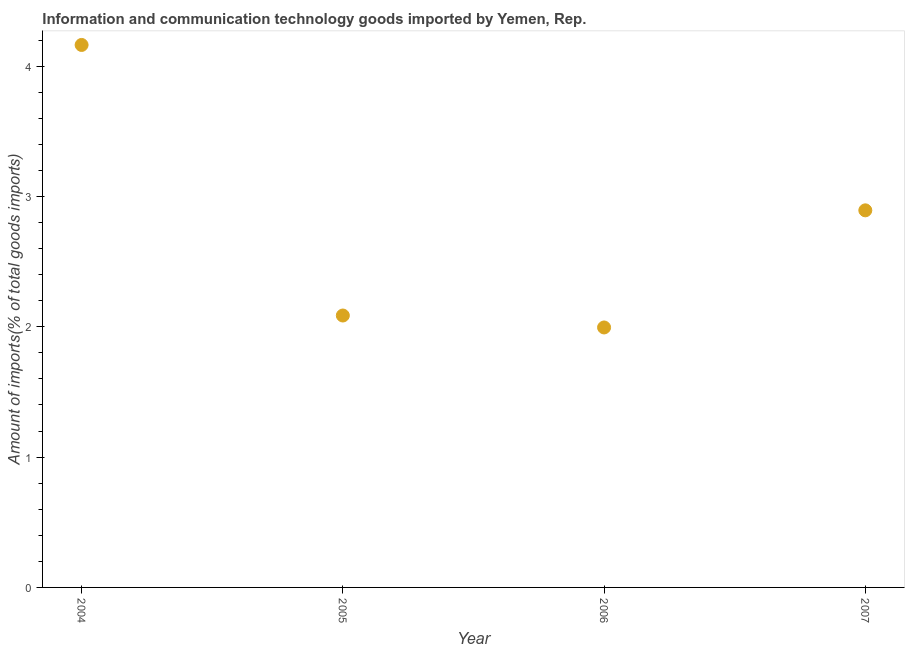What is the amount of ict goods imports in 2007?
Keep it short and to the point. 2.89. Across all years, what is the maximum amount of ict goods imports?
Keep it short and to the point. 4.16. Across all years, what is the minimum amount of ict goods imports?
Your answer should be very brief. 1.99. In which year was the amount of ict goods imports maximum?
Give a very brief answer. 2004. What is the sum of the amount of ict goods imports?
Provide a short and direct response. 11.14. What is the difference between the amount of ict goods imports in 2004 and 2005?
Give a very brief answer. 2.08. What is the average amount of ict goods imports per year?
Keep it short and to the point. 2.78. What is the median amount of ict goods imports?
Provide a succinct answer. 2.49. In how many years, is the amount of ict goods imports greater than 4 %?
Give a very brief answer. 1. Do a majority of the years between 2007 and 2004 (inclusive) have amount of ict goods imports greater than 2.2 %?
Provide a succinct answer. Yes. What is the ratio of the amount of ict goods imports in 2006 to that in 2007?
Provide a short and direct response. 0.69. What is the difference between the highest and the second highest amount of ict goods imports?
Offer a terse response. 1.27. Is the sum of the amount of ict goods imports in 2004 and 2007 greater than the maximum amount of ict goods imports across all years?
Provide a succinct answer. Yes. What is the difference between the highest and the lowest amount of ict goods imports?
Give a very brief answer. 2.17. In how many years, is the amount of ict goods imports greater than the average amount of ict goods imports taken over all years?
Make the answer very short. 2. How many dotlines are there?
Provide a short and direct response. 1. How many years are there in the graph?
Your answer should be compact. 4. What is the difference between two consecutive major ticks on the Y-axis?
Provide a succinct answer. 1. Does the graph contain grids?
Provide a short and direct response. No. What is the title of the graph?
Your answer should be compact. Information and communication technology goods imported by Yemen, Rep. What is the label or title of the Y-axis?
Offer a very short reply. Amount of imports(% of total goods imports). What is the Amount of imports(% of total goods imports) in 2004?
Ensure brevity in your answer.  4.16. What is the Amount of imports(% of total goods imports) in 2005?
Offer a terse response. 2.09. What is the Amount of imports(% of total goods imports) in 2006?
Keep it short and to the point. 1.99. What is the Amount of imports(% of total goods imports) in 2007?
Provide a succinct answer. 2.89. What is the difference between the Amount of imports(% of total goods imports) in 2004 and 2005?
Make the answer very short. 2.08. What is the difference between the Amount of imports(% of total goods imports) in 2004 and 2006?
Make the answer very short. 2.17. What is the difference between the Amount of imports(% of total goods imports) in 2004 and 2007?
Give a very brief answer. 1.27. What is the difference between the Amount of imports(% of total goods imports) in 2005 and 2006?
Offer a terse response. 0.09. What is the difference between the Amount of imports(% of total goods imports) in 2005 and 2007?
Make the answer very short. -0.81. What is the difference between the Amount of imports(% of total goods imports) in 2006 and 2007?
Ensure brevity in your answer.  -0.9. What is the ratio of the Amount of imports(% of total goods imports) in 2004 to that in 2005?
Keep it short and to the point. 2. What is the ratio of the Amount of imports(% of total goods imports) in 2004 to that in 2006?
Your answer should be very brief. 2.09. What is the ratio of the Amount of imports(% of total goods imports) in 2004 to that in 2007?
Ensure brevity in your answer.  1.44. What is the ratio of the Amount of imports(% of total goods imports) in 2005 to that in 2006?
Offer a terse response. 1.05. What is the ratio of the Amount of imports(% of total goods imports) in 2005 to that in 2007?
Offer a very short reply. 0.72. What is the ratio of the Amount of imports(% of total goods imports) in 2006 to that in 2007?
Your answer should be very brief. 0.69. 